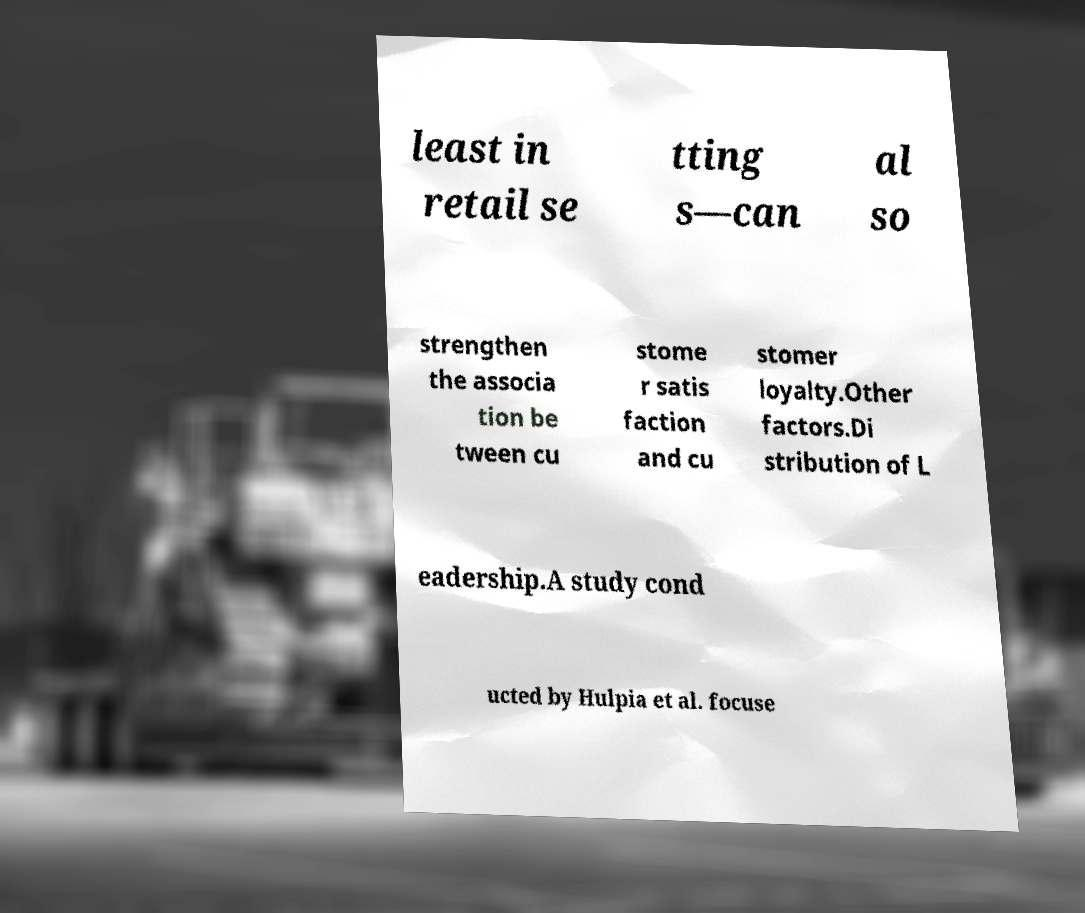I need the written content from this picture converted into text. Can you do that? least in retail se tting s—can al so strengthen the associa tion be tween cu stome r satis faction and cu stomer loyalty.Other factors.Di stribution of L eadership.A study cond ucted by Hulpia et al. focuse 